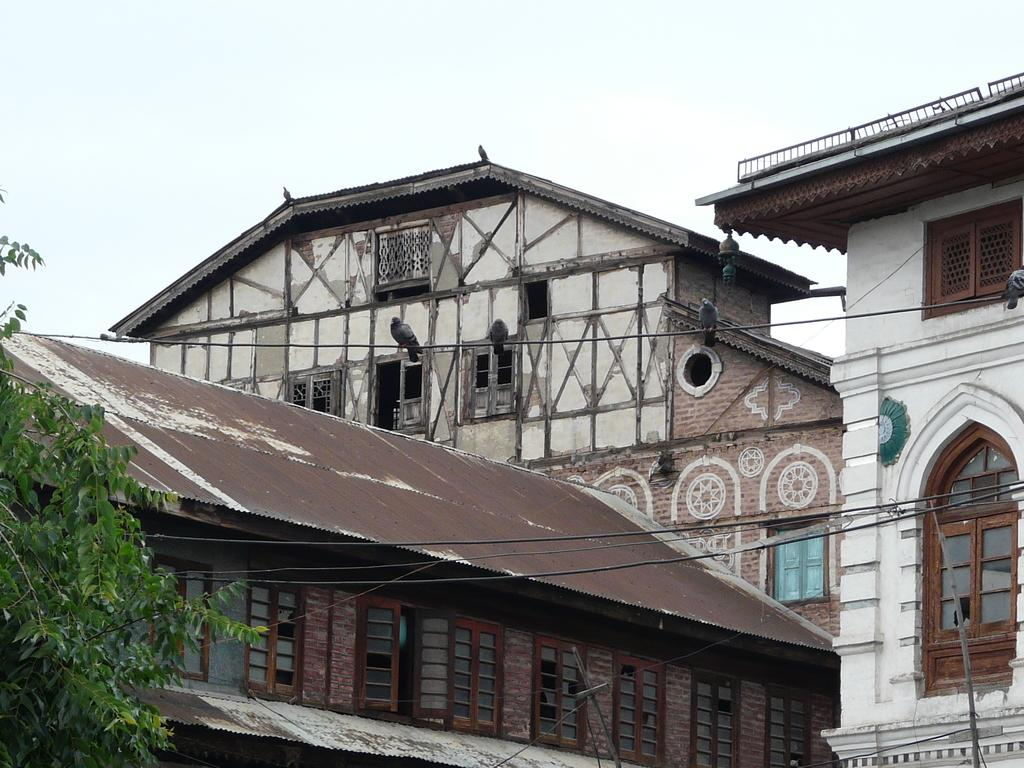What type of structures can be seen in the image? There are buildings in the image. What feature of the buildings is visible? There are windows visible on the buildings. What are the birds doing in the image? The birds are sitting on cables. What is visible at the top of the image? The sky is visible at the top of the image. What type of chance game is being played in the image? There is no chance game present in the image; it features buildings, windows, birds, and the sky. Is there a tent visible in the image? No, there is no tent present in the image. 